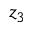<formula> <loc_0><loc_0><loc_500><loc_500>z _ { 3 }</formula> 